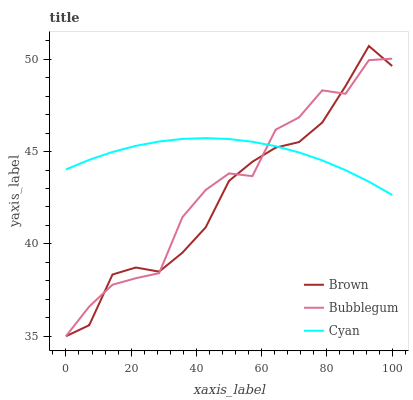Does Brown have the minimum area under the curve?
Answer yes or no. Yes. Does Cyan have the maximum area under the curve?
Answer yes or no. Yes. Does Bubblegum have the minimum area under the curve?
Answer yes or no. No. Does Bubblegum have the maximum area under the curve?
Answer yes or no. No. Is Cyan the smoothest?
Answer yes or no. Yes. Is Bubblegum the roughest?
Answer yes or no. Yes. Is Bubblegum the smoothest?
Answer yes or no. No. Is Cyan the roughest?
Answer yes or no. No. Does Brown have the lowest value?
Answer yes or no. Yes. Does Cyan have the lowest value?
Answer yes or no. No. Does Brown have the highest value?
Answer yes or no. Yes. Does Bubblegum have the highest value?
Answer yes or no. No. Does Bubblegum intersect Cyan?
Answer yes or no. Yes. Is Bubblegum less than Cyan?
Answer yes or no. No. Is Bubblegum greater than Cyan?
Answer yes or no. No. 